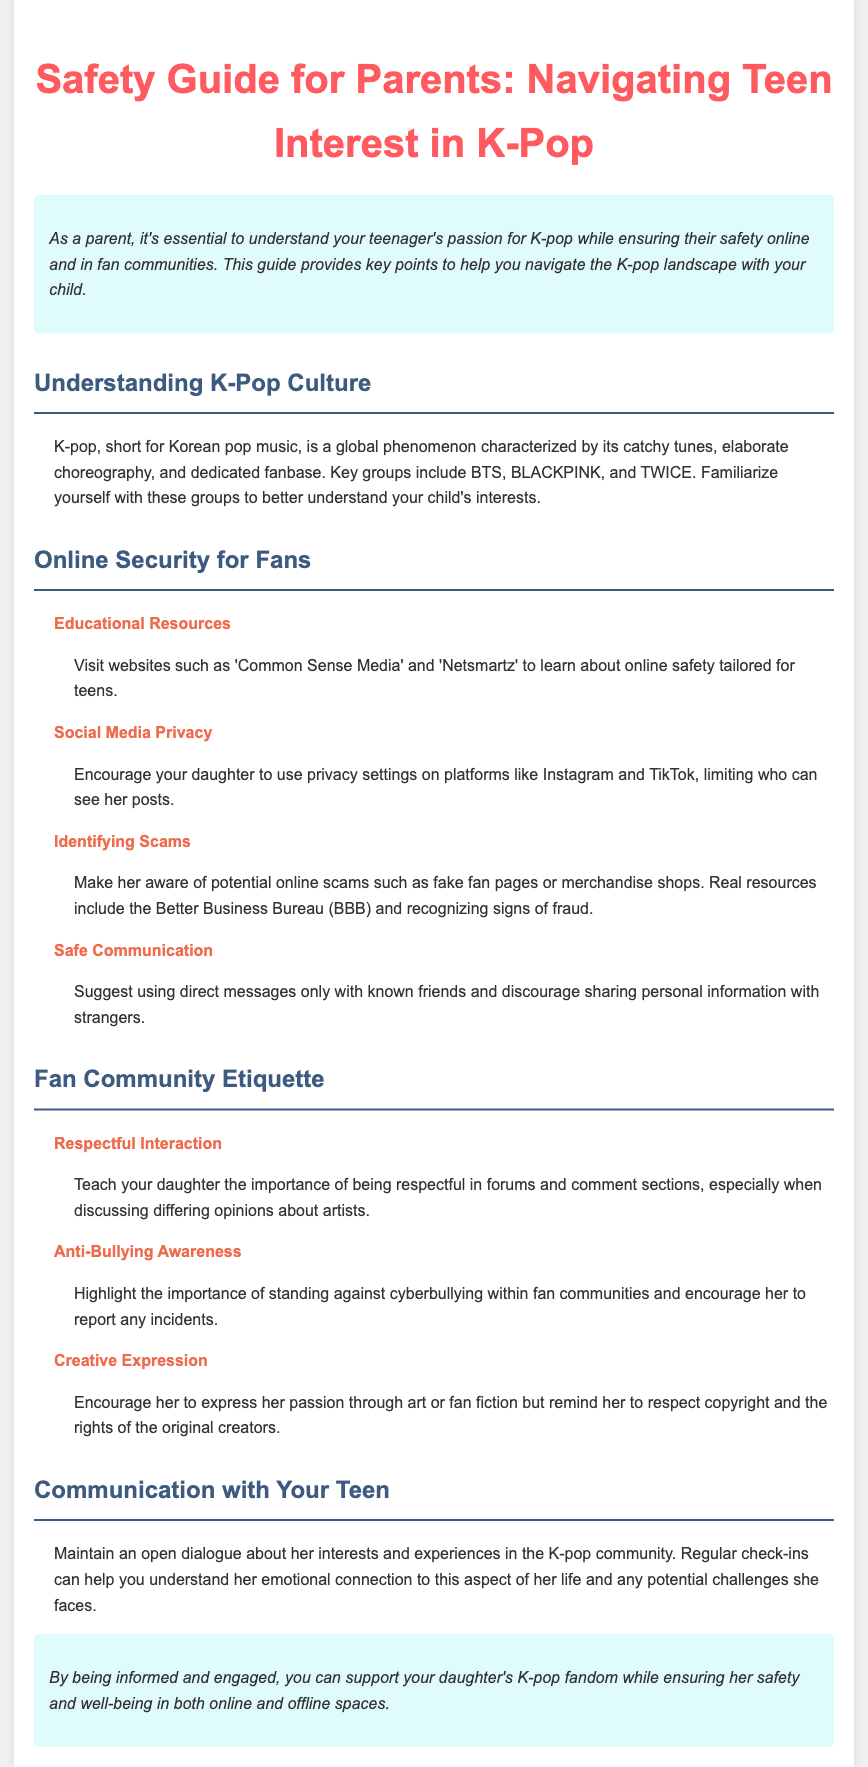what is K-pop short for? K-pop is defined as "Korean pop music" in the document.
Answer: Korean pop music who are some key K-pop groups mentioned? The document lists notable groups including BTS, BLACKPINK, and TWICE.
Answer: BTS, BLACKPINK, and TWICE what should parents encourage regarding social media privacy? The guide advises encouraging the use of privacy settings on social media platforms.
Answer: Use privacy settings what is one key point about respectful interaction? The document emphasizes the importance of being respectful when discussing differing opinions about artists.
Answer: Being respectful which organization can help identify online scams? The Better Business Bureau (BBB) is mentioned as a resource for identifying scams.
Answer: Better Business Bureau how should a parent maintain communication with their teenager? The guide suggests maintaining an open dialogue about her interests and experiences.
Answer: Open dialogue what should parents do if their child encounters cyberbullying? Parents are encouraged to highlight the importance of standing against and reporting incidents of cyberbullying.
Answer: Report incidents why is it important to understand K-pop culture? Understanding K-pop culture helps parents connect with their child's interests and passion.
Answer: Connect with interests 